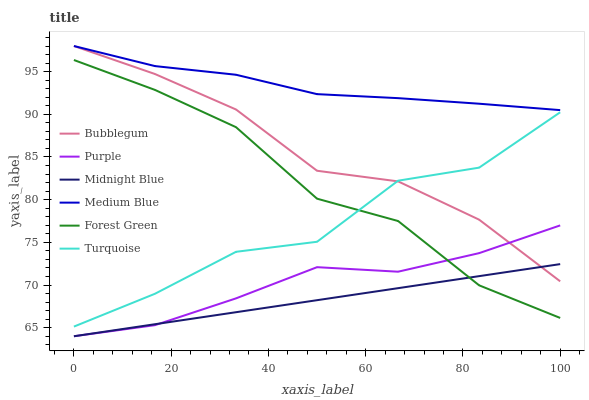Does Midnight Blue have the minimum area under the curve?
Answer yes or no. Yes. Does Medium Blue have the maximum area under the curve?
Answer yes or no. Yes. Does Purple have the minimum area under the curve?
Answer yes or no. No. Does Purple have the maximum area under the curve?
Answer yes or no. No. Is Midnight Blue the smoothest?
Answer yes or no. Yes. Is Turquoise the roughest?
Answer yes or no. Yes. Is Purple the smoothest?
Answer yes or no. No. Is Purple the roughest?
Answer yes or no. No. Does Midnight Blue have the lowest value?
Answer yes or no. Yes. Does Medium Blue have the lowest value?
Answer yes or no. No. Does Bubblegum have the highest value?
Answer yes or no. Yes. Does Purple have the highest value?
Answer yes or no. No. Is Purple less than Turquoise?
Answer yes or no. Yes. Is Turquoise greater than Purple?
Answer yes or no. Yes. Does Bubblegum intersect Turquoise?
Answer yes or no. Yes. Is Bubblegum less than Turquoise?
Answer yes or no. No. Is Bubblegum greater than Turquoise?
Answer yes or no. No. Does Purple intersect Turquoise?
Answer yes or no. No. 